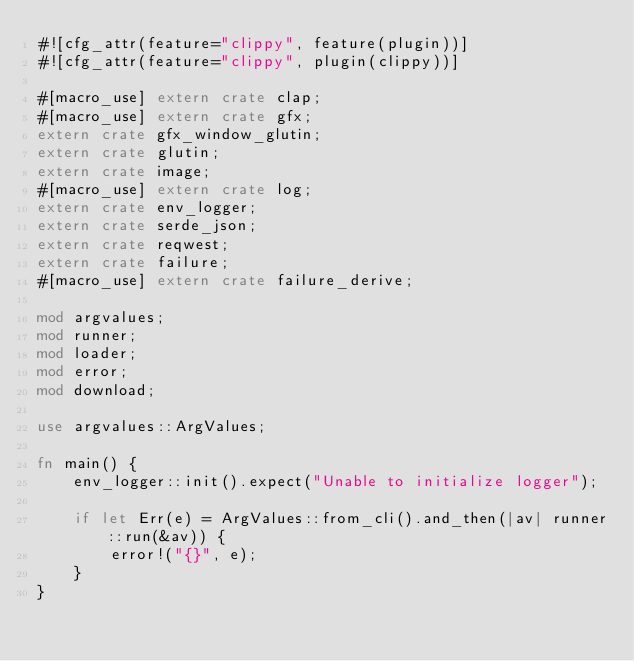<code> <loc_0><loc_0><loc_500><loc_500><_Rust_>#![cfg_attr(feature="clippy", feature(plugin))]
#![cfg_attr(feature="clippy", plugin(clippy))]

#[macro_use] extern crate clap;
#[macro_use] extern crate gfx;
extern crate gfx_window_glutin;
extern crate glutin;
extern crate image;
#[macro_use] extern crate log;
extern crate env_logger;
extern crate serde_json;
extern crate reqwest;
extern crate failure;
#[macro_use] extern crate failure_derive;

mod argvalues;
mod runner;
mod loader;
mod error;
mod download;

use argvalues::ArgValues;

fn main() {
    env_logger::init().expect("Unable to initialize logger");

    if let Err(e) = ArgValues::from_cli().and_then(|av| runner::run(&av)) {
        error!("{}", e);
    }
}
</code> 